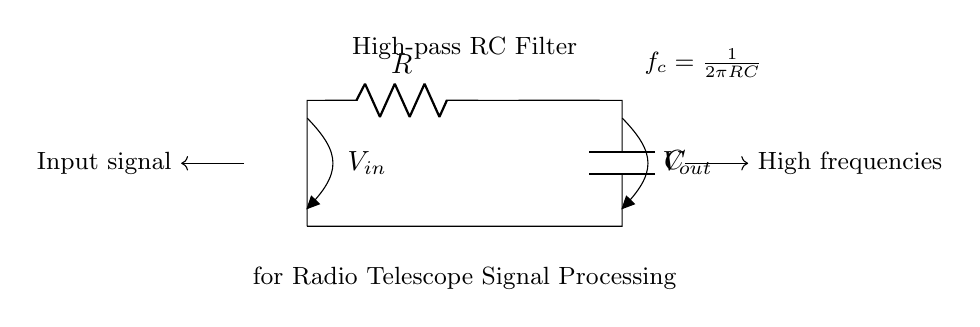What components are present in this circuit? The circuit contains two components: a resistor and a capacitor. These are indicated by the symbols R and C respectively, connected in a specific configuration.
Answer: Resistor and Capacitor What is the function of this circuit? This circuit is a high-pass RC filter, which allows high-frequency signals to pass while attenuating lower frequencies, specifically designed for processing radio telescope signals.
Answer: High-pass filter What is the input signal labeled as? The input signal is represented in the diagram with the label V in, indicating the voltage entering the circuit.
Answer: V in What is the formula for the cutoff frequency? The cutoff frequency is given by the formula f c = 1 over 2 pi R C, which is crucial to determine the frequency at which the output signal begins to drop off.
Answer: f c = 1 over 2 pi R C How do high frequencies affect the output? High frequencies contribute to an increased output voltage in this circuit, as the design allows these frequencies to pass through effectively while blocking lower frequencies.
Answer: Increased output What would happen if the resistor value increases? Increasing the resistance would lower the cutoff frequency, leading to a shift in the spectrum of signals that are passed through by the filter, as determined by the RC time constant.
Answer: Lower cutoff frequency Why is this filter important for radio telescope signal processing? This filter is crucial for reducing noise from lower frequency signals, thereby allowing for clearer detection and processing of the desired high-frequency astronomical signals captured by the radio telescope.
Answer: Reduces noise 